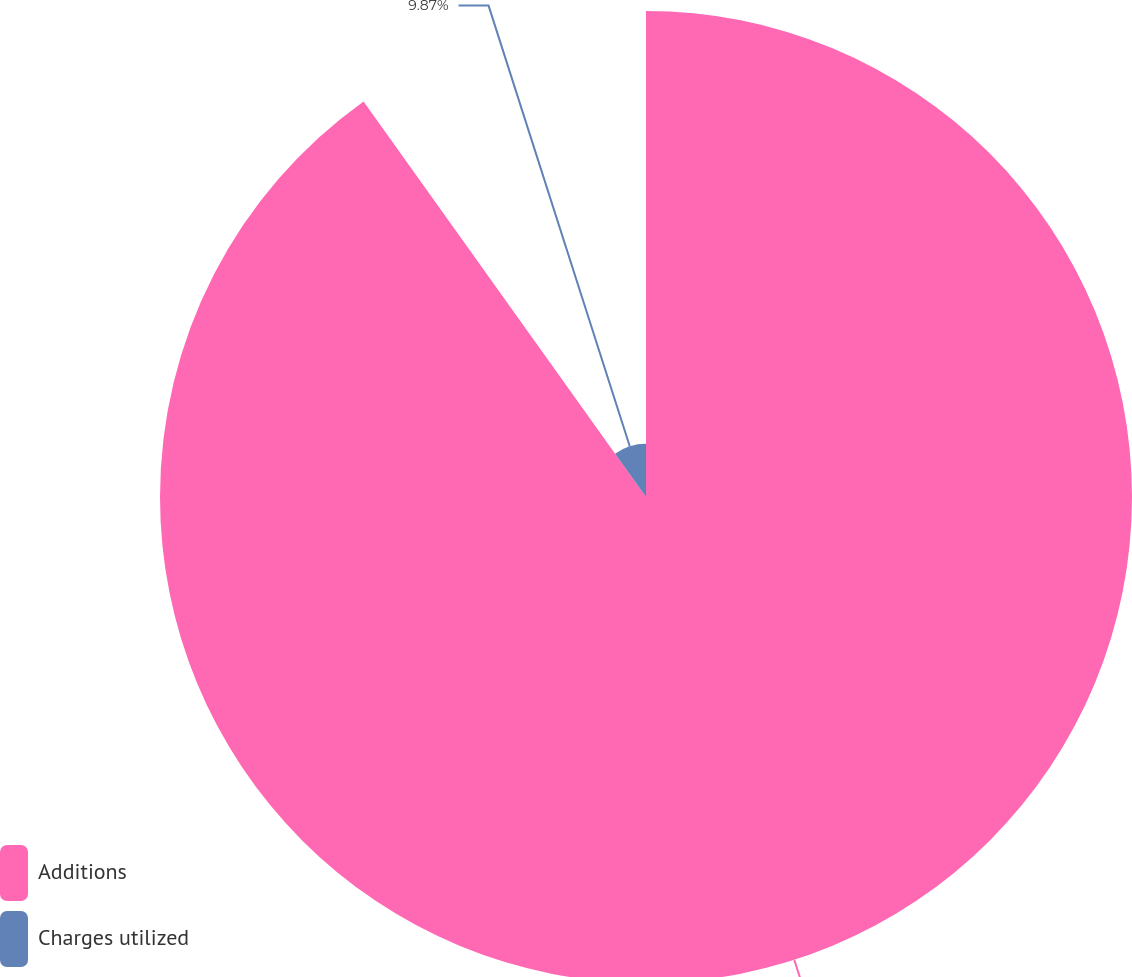Convert chart. <chart><loc_0><loc_0><loc_500><loc_500><pie_chart><fcel>Additions<fcel>Charges utilized<nl><fcel>90.13%<fcel>9.87%<nl></chart> 